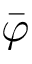Convert formula to latex. <formula><loc_0><loc_0><loc_500><loc_500>\bar { \varphi }</formula> 